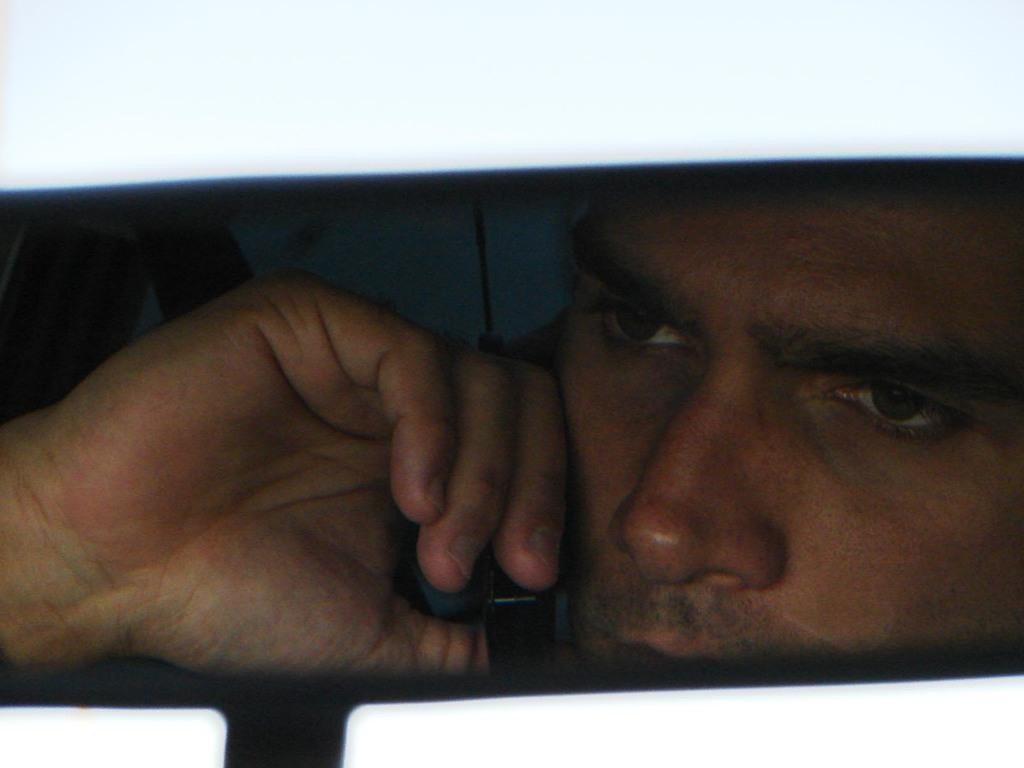What is the main subject of the image? There is a person in the image. What type of sock is the person wearing in the image? There is no information about the person's clothing or accessories, so it cannot be determined if they are wearing a sock or what type it might be. 